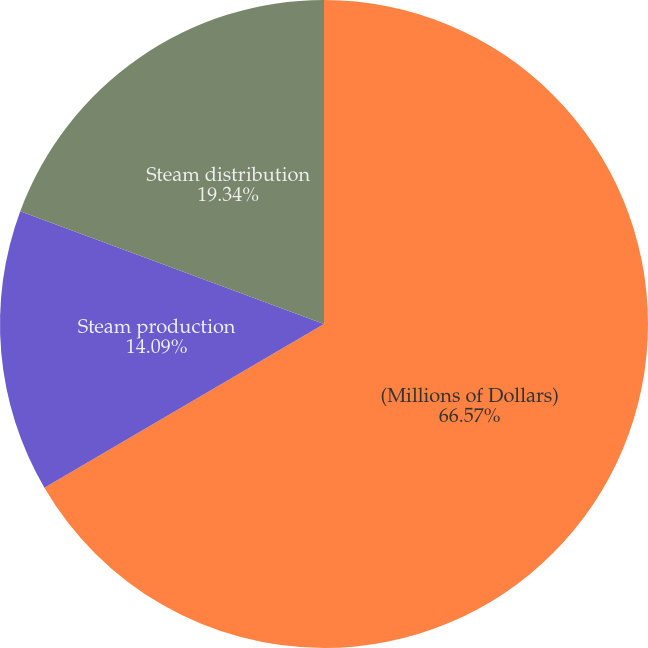Convert chart to OTSL. <chart><loc_0><loc_0><loc_500><loc_500><pie_chart><fcel>(Millions of Dollars)<fcel>Steam production<fcel>Steam distribution<nl><fcel>66.57%<fcel>14.09%<fcel>19.34%<nl></chart> 